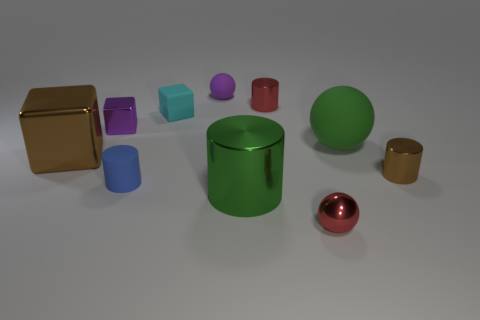Subtract 1 cylinders. How many cylinders are left? 3 Subtract all cubes. How many objects are left? 7 Subtract all large green balls. Subtract all small gray shiny balls. How many objects are left? 9 Add 3 purple metal cubes. How many purple metal cubes are left? 4 Add 2 large gray spheres. How many large gray spheres exist? 2 Subtract 1 red spheres. How many objects are left? 9 